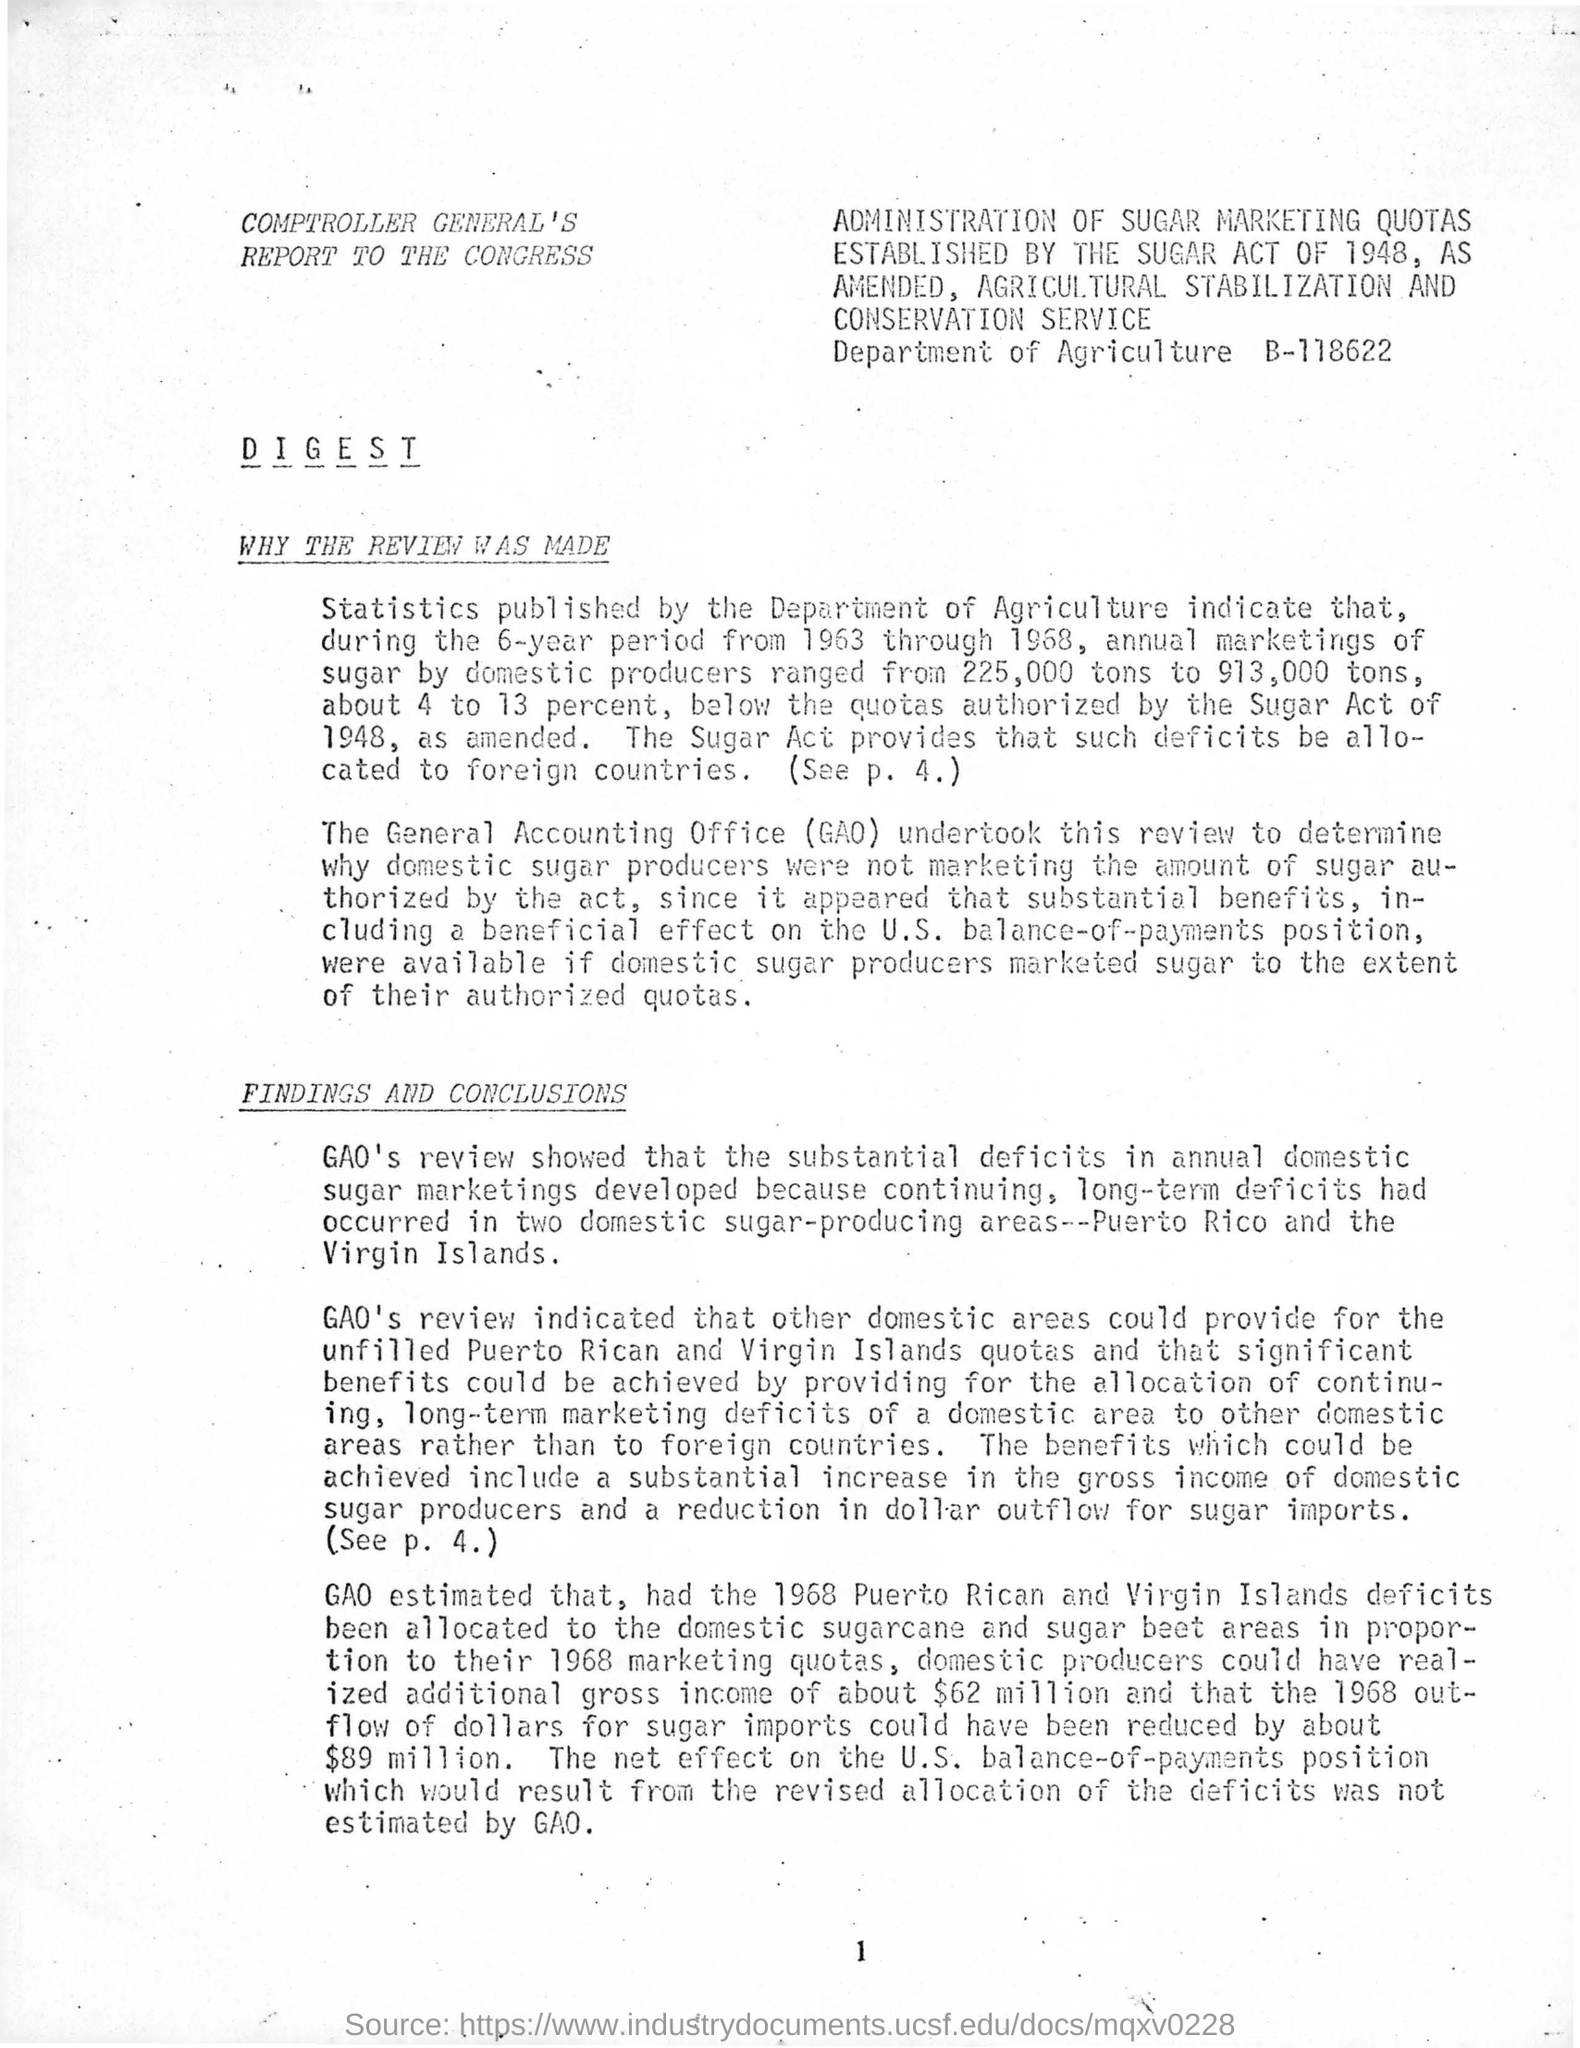Mention a couple of crucial points in this snapshot. What is the Page Number? It ranges from 1 to... 